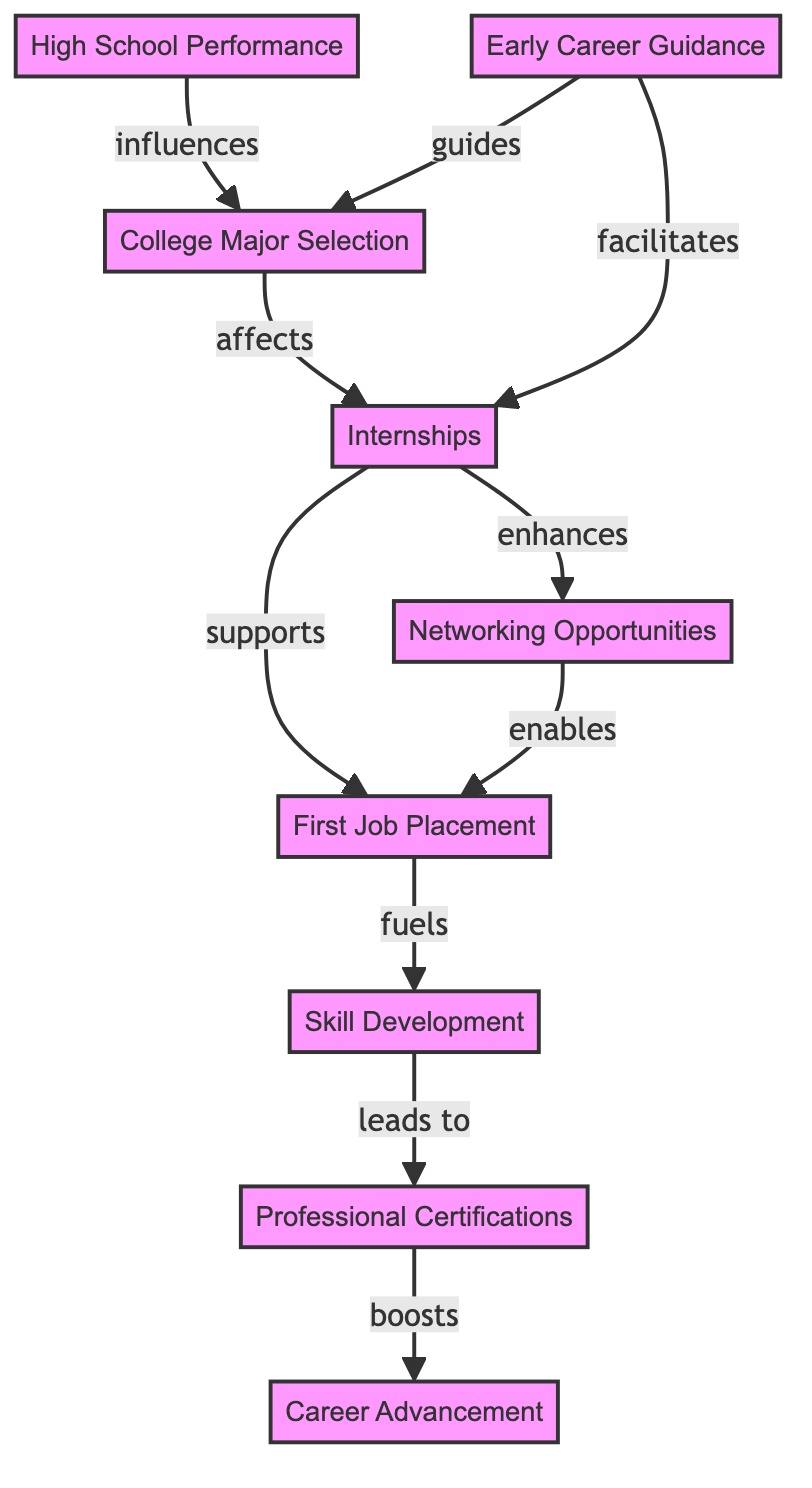What node influences College Major Selection? The diagram shows that High School Performance directly points to College Major Selection with the label "influences".
Answer: High School Performance How many nodes are present in the diagram? By counting the distinct entities (nodes) listed in the data, there are a total of nine: High School Performance, College Major Selection, Early Career Guidance, Internships, Networking Opportunities, First Job Placement, Skill Development, Professional Certifications, and Career Advancement.
Answer: 9 What is the relationship between Early Career Guidance and Internships? The edge between Early Career Guidance and Internships is labeled "facilitates", indicating that Early Career Guidance plays a role in enabling or helping to achieve Internships.
Answer: facilitates Which node is the final outcome in the flow of the graph? Tracing the edges from the starting nodes, we find that the final node that is reached, where all influences lead to, is Career Advancement.
Answer: Career Advancement Which node is supported by Internships? According to the diagram, Internships have an outgoing edge to First Job Placement with the label "supports", indicating that they play a supportive role in achieving the First Job Placement.
Answer: First Job Placement What leads to Professional Certifications? The edge from Skill Development to Professional Certifications shows clearly that Skill Development is a precursor or contributor to obtaining Professional Certifications.
Answer: Skill Development How does Networking Opportunities influence First Job Placement? The directed edge from Networking Opportunities to First Job Placement is labeled "enables", indicating that Networking Opportunities play a part in making First Job Placement possible.
Answer: enables What boosts Career Advancement? The diagram indicates that Professional Certifications have a direct edge to Career Advancement with the label "boosts", showing that obtaining certifications enhances the chances of advancing in a career.
Answer: boosts Which node is affected by College Major Selection? The diagram illustrates an arrow from College Major Selection to Internships with the label "affects", suggesting that the choice of a college major plays an important role in the opportunities for Internships.
Answer: Internships 